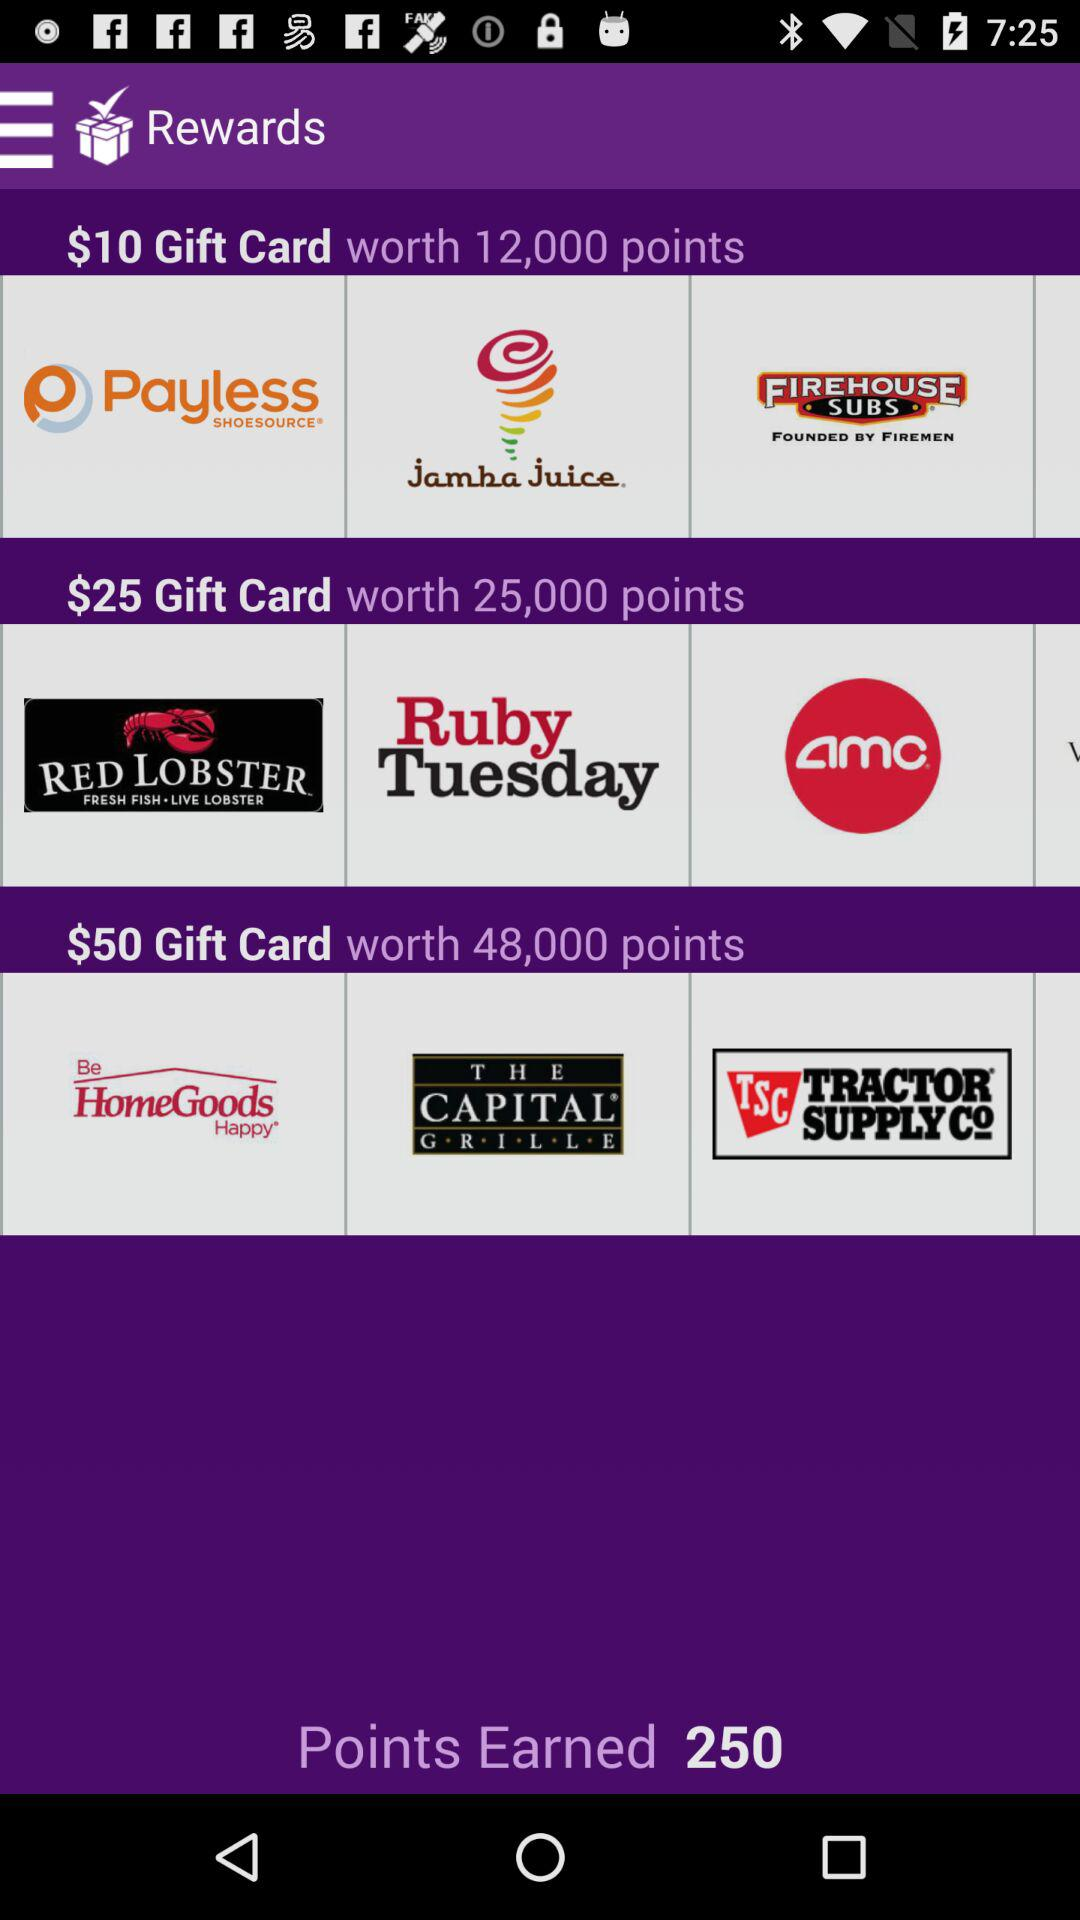What's the value of the $10 gift card? The value of the $10 gift card is 12,000 points. 